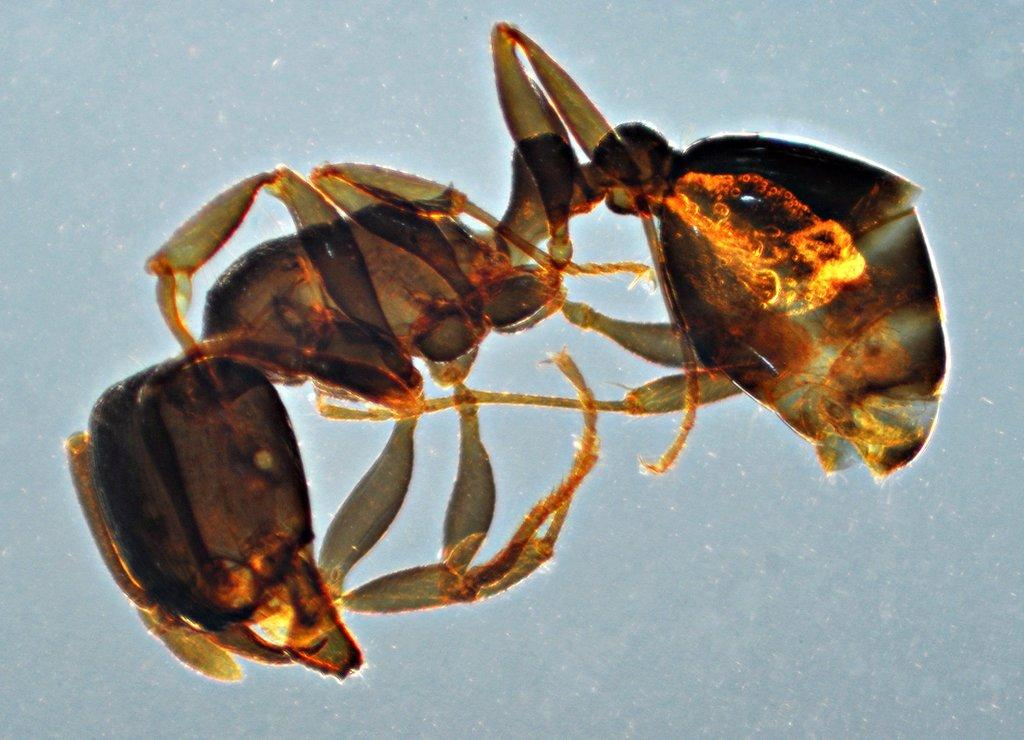What type of creature can be seen in the image? There is an insect in the image. What color is the background of the image? The background of the image is white in color. Where is the park located in the image? There is no park present in the image; it only features an insect and a white background. What type of material is the insect using to lead the way in the image? There is no indication of the insect leading anything in the image, and insects do not use materials to lead. 